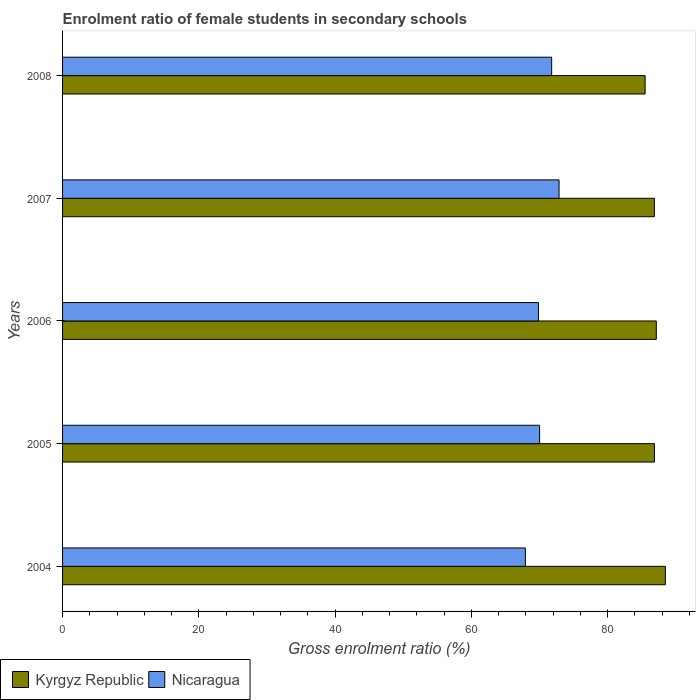How many groups of bars are there?
Provide a short and direct response. 5. Are the number of bars per tick equal to the number of legend labels?
Your response must be concise. Yes. How many bars are there on the 1st tick from the bottom?
Make the answer very short. 2. In how many cases, is the number of bars for a given year not equal to the number of legend labels?
Your response must be concise. 0. What is the enrolment ratio of female students in secondary schools in Nicaragua in 2006?
Give a very brief answer. 69.85. Across all years, what is the maximum enrolment ratio of female students in secondary schools in Kyrgyz Republic?
Offer a terse response. 88.47. Across all years, what is the minimum enrolment ratio of female students in secondary schools in Nicaragua?
Offer a terse response. 67.93. In which year was the enrolment ratio of female students in secondary schools in Kyrgyz Republic minimum?
Offer a terse response. 2008. What is the total enrolment ratio of female students in secondary schools in Nicaragua in the graph?
Offer a very short reply. 352.44. What is the difference between the enrolment ratio of female students in secondary schools in Nicaragua in 2005 and that in 2008?
Your answer should be compact. -1.77. What is the difference between the enrolment ratio of female students in secondary schools in Kyrgyz Republic in 2004 and the enrolment ratio of female students in secondary schools in Nicaragua in 2005?
Make the answer very short. 18.45. What is the average enrolment ratio of female students in secondary schools in Nicaragua per year?
Make the answer very short. 70.49. In the year 2008, what is the difference between the enrolment ratio of female students in secondary schools in Kyrgyz Republic and enrolment ratio of female students in secondary schools in Nicaragua?
Give a very brief answer. 13.72. In how many years, is the enrolment ratio of female students in secondary schools in Kyrgyz Republic greater than 76 %?
Make the answer very short. 5. What is the ratio of the enrolment ratio of female students in secondary schools in Nicaragua in 2004 to that in 2005?
Ensure brevity in your answer.  0.97. Is the difference between the enrolment ratio of female students in secondary schools in Kyrgyz Republic in 2007 and 2008 greater than the difference between the enrolment ratio of female students in secondary schools in Nicaragua in 2007 and 2008?
Offer a terse response. Yes. What is the difference between the highest and the second highest enrolment ratio of female students in secondary schools in Kyrgyz Republic?
Make the answer very short. 1.33. What is the difference between the highest and the lowest enrolment ratio of female students in secondary schools in Kyrgyz Republic?
Offer a very short reply. 2.97. Is the sum of the enrolment ratio of female students in secondary schools in Nicaragua in 2004 and 2005 greater than the maximum enrolment ratio of female students in secondary schools in Kyrgyz Republic across all years?
Your answer should be compact. Yes. What does the 2nd bar from the top in 2008 represents?
Make the answer very short. Kyrgyz Republic. What does the 2nd bar from the bottom in 2008 represents?
Your response must be concise. Nicaragua. How many bars are there?
Provide a succinct answer. 10. Are all the bars in the graph horizontal?
Offer a terse response. Yes. How many years are there in the graph?
Make the answer very short. 5. What is the difference between two consecutive major ticks on the X-axis?
Give a very brief answer. 20. Does the graph contain any zero values?
Provide a short and direct response. No. How many legend labels are there?
Give a very brief answer. 2. What is the title of the graph?
Provide a short and direct response. Enrolment ratio of female students in secondary schools. Does "Solomon Islands" appear as one of the legend labels in the graph?
Your answer should be compact. No. What is the label or title of the X-axis?
Provide a short and direct response. Gross enrolment ratio (%). What is the label or title of the Y-axis?
Provide a succinct answer. Years. What is the Gross enrolment ratio (%) of Kyrgyz Republic in 2004?
Your response must be concise. 88.47. What is the Gross enrolment ratio (%) of Nicaragua in 2004?
Give a very brief answer. 67.93. What is the Gross enrolment ratio (%) in Kyrgyz Republic in 2005?
Ensure brevity in your answer.  86.87. What is the Gross enrolment ratio (%) in Nicaragua in 2005?
Your answer should be very brief. 70.01. What is the Gross enrolment ratio (%) in Kyrgyz Republic in 2006?
Give a very brief answer. 87.14. What is the Gross enrolment ratio (%) of Nicaragua in 2006?
Your answer should be very brief. 69.85. What is the Gross enrolment ratio (%) of Kyrgyz Republic in 2007?
Make the answer very short. 86.86. What is the Gross enrolment ratio (%) in Nicaragua in 2007?
Give a very brief answer. 72.87. What is the Gross enrolment ratio (%) of Kyrgyz Republic in 2008?
Make the answer very short. 85.5. What is the Gross enrolment ratio (%) of Nicaragua in 2008?
Provide a succinct answer. 71.78. Across all years, what is the maximum Gross enrolment ratio (%) of Kyrgyz Republic?
Make the answer very short. 88.47. Across all years, what is the maximum Gross enrolment ratio (%) in Nicaragua?
Offer a very short reply. 72.87. Across all years, what is the minimum Gross enrolment ratio (%) in Kyrgyz Republic?
Provide a succinct answer. 85.5. Across all years, what is the minimum Gross enrolment ratio (%) in Nicaragua?
Offer a very short reply. 67.93. What is the total Gross enrolment ratio (%) of Kyrgyz Republic in the graph?
Your response must be concise. 434.85. What is the total Gross enrolment ratio (%) of Nicaragua in the graph?
Your answer should be compact. 352.44. What is the difference between the Gross enrolment ratio (%) in Kyrgyz Republic in 2004 and that in 2005?
Your answer should be compact. 1.59. What is the difference between the Gross enrolment ratio (%) in Nicaragua in 2004 and that in 2005?
Provide a succinct answer. -2.09. What is the difference between the Gross enrolment ratio (%) of Kyrgyz Republic in 2004 and that in 2006?
Make the answer very short. 1.33. What is the difference between the Gross enrolment ratio (%) of Nicaragua in 2004 and that in 2006?
Your answer should be very brief. -1.92. What is the difference between the Gross enrolment ratio (%) in Kyrgyz Republic in 2004 and that in 2007?
Make the answer very short. 1.61. What is the difference between the Gross enrolment ratio (%) of Nicaragua in 2004 and that in 2007?
Give a very brief answer. -4.94. What is the difference between the Gross enrolment ratio (%) in Kyrgyz Republic in 2004 and that in 2008?
Keep it short and to the point. 2.97. What is the difference between the Gross enrolment ratio (%) in Nicaragua in 2004 and that in 2008?
Keep it short and to the point. -3.86. What is the difference between the Gross enrolment ratio (%) of Kyrgyz Republic in 2005 and that in 2006?
Give a very brief answer. -0.27. What is the difference between the Gross enrolment ratio (%) of Nicaragua in 2005 and that in 2006?
Your response must be concise. 0.17. What is the difference between the Gross enrolment ratio (%) of Kyrgyz Republic in 2005 and that in 2007?
Your response must be concise. 0.02. What is the difference between the Gross enrolment ratio (%) in Nicaragua in 2005 and that in 2007?
Provide a succinct answer. -2.85. What is the difference between the Gross enrolment ratio (%) of Kyrgyz Republic in 2005 and that in 2008?
Ensure brevity in your answer.  1.37. What is the difference between the Gross enrolment ratio (%) of Nicaragua in 2005 and that in 2008?
Make the answer very short. -1.77. What is the difference between the Gross enrolment ratio (%) in Kyrgyz Republic in 2006 and that in 2007?
Your answer should be very brief. 0.28. What is the difference between the Gross enrolment ratio (%) in Nicaragua in 2006 and that in 2007?
Make the answer very short. -3.02. What is the difference between the Gross enrolment ratio (%) in Kyrgyz Republic in 2006 and that in 2008?
Your answer should be compact. 1.64. What is the difference between the Gross enrolment ratio (%) in Nicaragua in 2006 and that in 2008?
Provide a succinct answer. -1.94. What is the difference between the Gross enrolment ratio (%) of Kyrgyz Republic in 2007 and that in 2008?
Provide a succinct answer. 1.36. What is the difference between the Gross enrolment ratio (%) of Nicaragua in 2007 and that in 2008?
Provide a succinct answer. 1.08. What is the difference between the Gross enrolment ratio (%) in Kyrgyz Republic in 2004 and the Gross enrolment ratio (%) in Nicaragua in 2005?
Your answer should be very brief. 18.45. What is the difference between the Gross enrolment ratio (%) in Kyrgyz Republic in 2004 and the Gross enrolment ratio (%) in Nicaragua in 2006?
Offer a very short reply. 18.62. What is the difference between the Gross enrolment ratio (%) of Kyrgyz Republic in 2004 and the Gross enrolment ratio (%) of Nicaragua in 2007?
Keep it short and to the point. 15.6. What is the difference between the Gross enrolment ratio (%) of Kyrgyz Republic in 2004 and the Gross enrolment ratio (%) of Nicaragua in 2008?
Your response must be concise. 16.69. What is the difference between the Gross enrolment ratio (%) in Kyrgyz Republic in 2005 and the Gross enrolment ratio (%) in Nicaragua in 2006?
Your answer should be very brief. 17.03. What is the difference between the Gross enrolment ratio (%) of Kyrgyz Republic in 2005 and the Gross enrolment ratio (%) of Nicaragua in 2007?
Your answer should be very brief. 14.01. What is the difference between the Gross enrolment ratio (%) of Kyrgyz Republic in 2005 and the Gross enrolment ratio (%) of Nicaragua in 2008?
Your answer should be compact. 15.09. What is the difference between the Gross enrolment ratio (%) in Kyrgyz Republic in 2006 and the Gross enrolment ratio (%) in Nicaragua in 2007?
Your answer should be compact. 14.27. What is the difference between the Gross enrolment ratio (%) of Kyrgyz Republic in 2006 and the Gross enrolment ratio (%) of Nicaragua in 2008?
Your answer should be very brief. 15.36. What is the difference between the Gross enrolment ratio (%) in Kyrgyz Republic in 2007 and the Gross enrolment ratio (%) in Nicaragua in 2008?
Offer a very short reply. 15.07. What is the average Gross enrolment ratio (%) in Kyrgyz Republic per year?
Offer a very short reply. 86.97. What is the average Gross enrolment ratio (%) of Nicaragua per year?
Your answer should be very brief. 70.49. In the year 2004, what is the difference between the Gross enrolment ratio (%) of Kyrgyz Republic and Gross enrolment ratio (%) of Nicaragua?
Make the answer very short. 20.54. In the year 2005, what is the difference between the Gross enrolment ratio (%) in Kyrgyz Republic and Gross enrolment ratio (%) in Nicaragua?
Your answer should be compact. 16.86. In the year 2006, what is the difference between the Gross enrolment ratio (%) in Kyrgyz Republic and Gross enrolment ratio (%) in Nicaragua?
Provide a succinct answer. 17.3. In the year 2007, what is the difference between the Gross enrolment ratio (%) in Kyrgyz Republic and Gross enrolment ratio (%) in Nicaragua?
Keep it short and to the point. 13.99. In the year 2008, what is the difference between the Gross enrolment ratio (%) in Kyrgyz Republic and Gross enrolment ratio (%) in Nicaragua?
Provide a succinct answer. 13.72. What is the ratio of the Gross enrolment ratio (%) in Kyrgyz Republic in 2004 to that in 2005?
Make the answer very short. 1.02. What is the ratio of the Gross enrolment ratio (%) of Nicaragua in 2004 to that in 2005?
Provide a succinct answer. 0.97. What is the ratio of the Gross enrolment ratio (%) of Kyrgyz Republic in 2004 to that in 2006?
Offer a terse response. 1.02. What is the ratio of the Gross enrolment ratio (%) in Nicaragua in 2004 to that in 2006?
Provide a succinct answer. 0.97. What is the ratio of the Gross enrolment ratio (%) in Kyrgyz Republic in 2004 to that in 2007?
Offer a terse response. 1.02. What is the ratio of the Gross enrolment ratio (%) of Nicaragua in 2004 to that in 2007?
Keep it short and to the point. 0.93. What is the ratio of the Gross enrolment ratio (%) in Kyrgyz Republic in 2004 to that in 2008?
Provide a succinct answer. 1.03. What is the ratio of the Gross enrolment ratio (%) in Nicaragua in 2004 to that in 2008?
Give a very brief answer. 0.95. What is the ratio of the Gross enrolment ratio (%) of Nicaragua in 2005 to that in 2007?
Your response must be concise. 0.96. What is the ratio of the Gross enrolment ratio (%) of Kyrgyz Republic in 2005 to that in 2008?
Ensure brevity in your answer.  1.02. What is the ratio of the Gross enrolment ratio (%) of Nicaragua in 2005 to that in 2008?
Your answer should be compact. 0.98. What is the ratio of the Gross enrolment ratio (%) of Kyrgyz Republic in 2006 to that in 2007?
Ensure brevity in your answer.  1. What is the ratio of the Gross enrolment ratio (%) of Nicaragua in 2006 to that in 2007?
Provide a short and direct response. 0.96. What is the ratio of the Gross enrolment ratio (%) of Kyrgyz Republic in 2006 to that in 2008?
Provide a succinct answer. 1.02. What is the ratio of the Gross enrolment ratio (%) in Nicaragua in 2006 to that in 2008?
Your answer should be compact. 0.97. What is the ratio of the Gross enrolment ratio (%) in Kyrgyz Republic in 2007 to that in 2008?
Offer a very short reply. 1.02. What is the ratio of the Gross enrolment ratio (%) in Nicaragua in 2007 to that in 2008?
Ensure brevity in your answer.  1.02. What is the difference between the highest and the second highest Gross enrolment ratio (%) of Kyrgyz Republic?
Provide a short and direct response. 1.33. What is the difference between the highest and the second highest Gross enrolment ratio (%) in Nicaragua?
Offer a terse response. 1.08. What is the difference between the highest and the lowest Gross enrolment ratio (%) in Kyrgyz Republic?
Offer a terse response. 2.97. What is the difference between the highest and the lowest Gross enrolment ratio (%) of Nicaragua?
Offer a terse response. 4.94. 